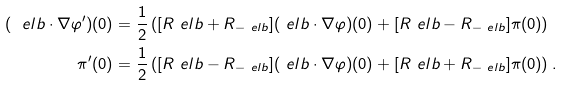<formula> <loc_0><loc_0><loc_500><loc_500>( \ e l b \cdot \nabla \varphi ^ { \prime } ) ( 0 ) & = \frac { 1 } { 2 } \left ( [ R _ { \ } e l b + R _ { - \ e l b } ] ( \ e l b \cdot \nabla \varphi ) ( 0 ) + [ R _ { \ } e l b - R _ { - \ e l b } ] \pi ( 0 ) \right ) \\ \pi ^ { \prime } ( 0 ) & = \frac { 1 } { 2 } \left ( [ R _ { \ } e l b - R _ { - \ e l b } ] ( \ e l b \cdot \nabla \varphi ) ( 0 ) + [ R _ { \ } e l b + R _ { - \ e l b } ] \pi ( 0 ) \right ) .</formula> 